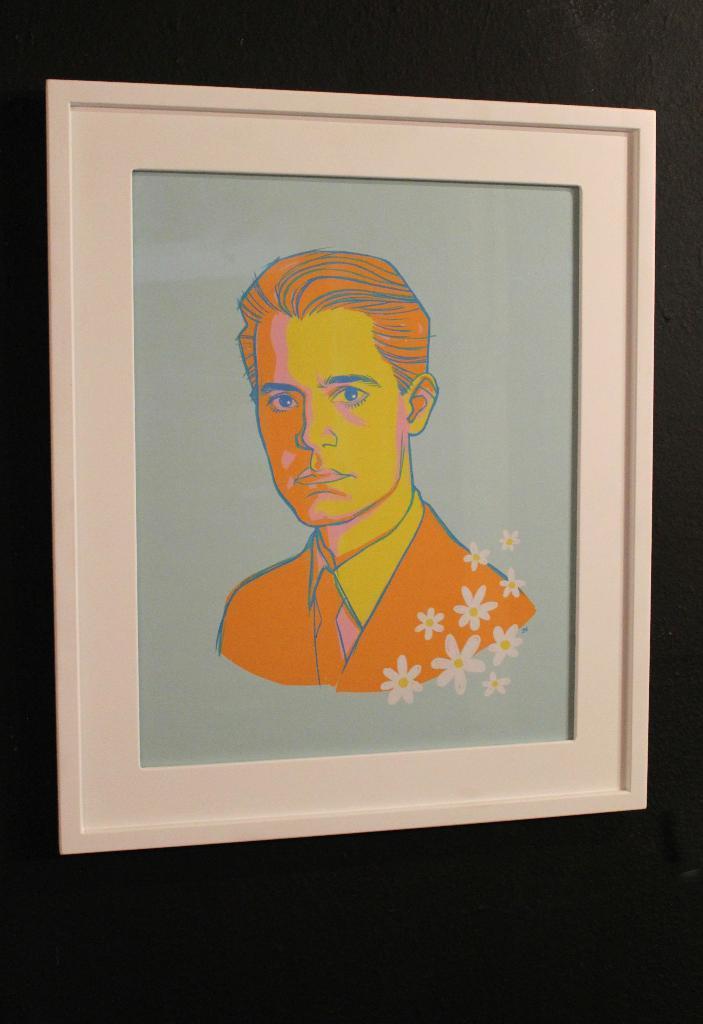Can you describe this image briefly? In the center of the image there is a photo frame in which there is a depiction of a person. 